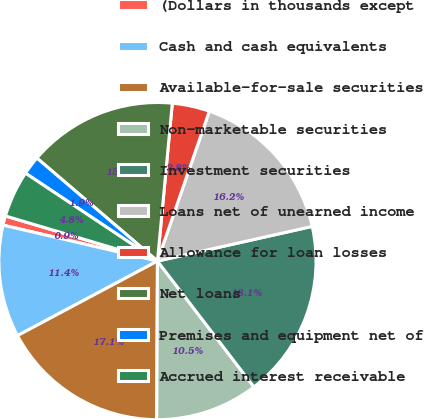Convert chart to OTSL. <chart><loc_0><loc_0><loc_500><loc_500><pie_chart><fcel>(Dollars in thousands except<fcel>Cash and cash equivalents<fcel>Available-for-sale securities<fcel>Non-marketable securities<fcel>Investment securities<fcel>Loans net of unearned income<fcel>Allowance for loan losses<fcel>Net loans<fcel>Premises and equipment net of<fcel>Accrued interest receivable<nl><fcel>0.95%<fcel>11.43%<fcel>17.14%<fcel>10.48%<fcel>18.1%<fcel>16.19%<fcel>3.81%<fcel>15.24%<fcel>1.9%<fcel>4.76%<nl></chart> 